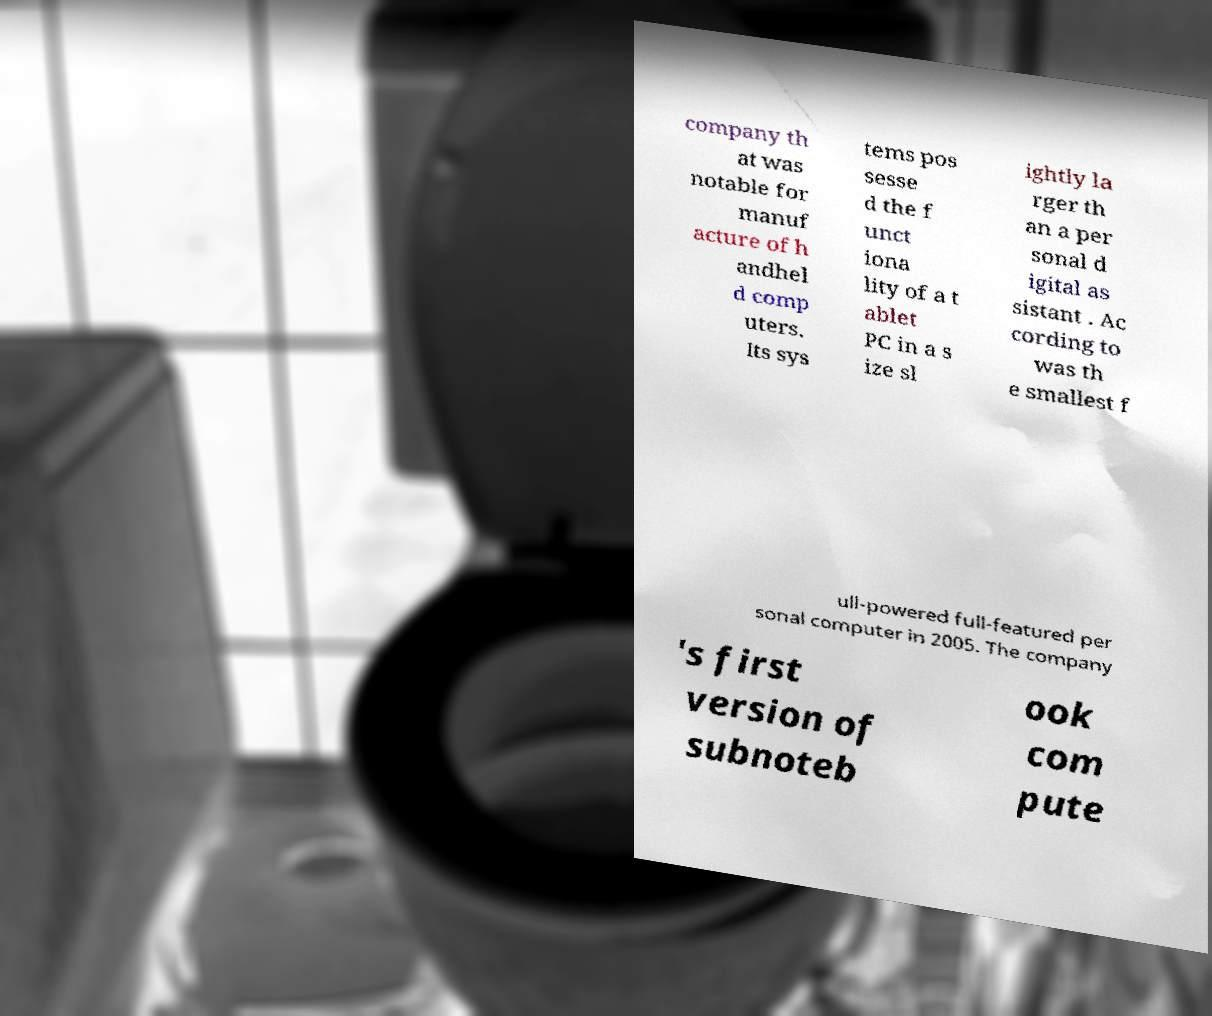Could you assist in decoding the text presented in this image and type it out clearly? company th at was notable for manuf acture of h andhel d comp uters. Its sys tems pos sesse d the f unct iona lity of a t ablet PC in a s ize sl ightly la rger th an a per sonal d igital as sistant . Ac cording to was th e smallest f ull-powered full-featured per sonal computer in 2005. The company 's first version of subnoteb ook com pute 